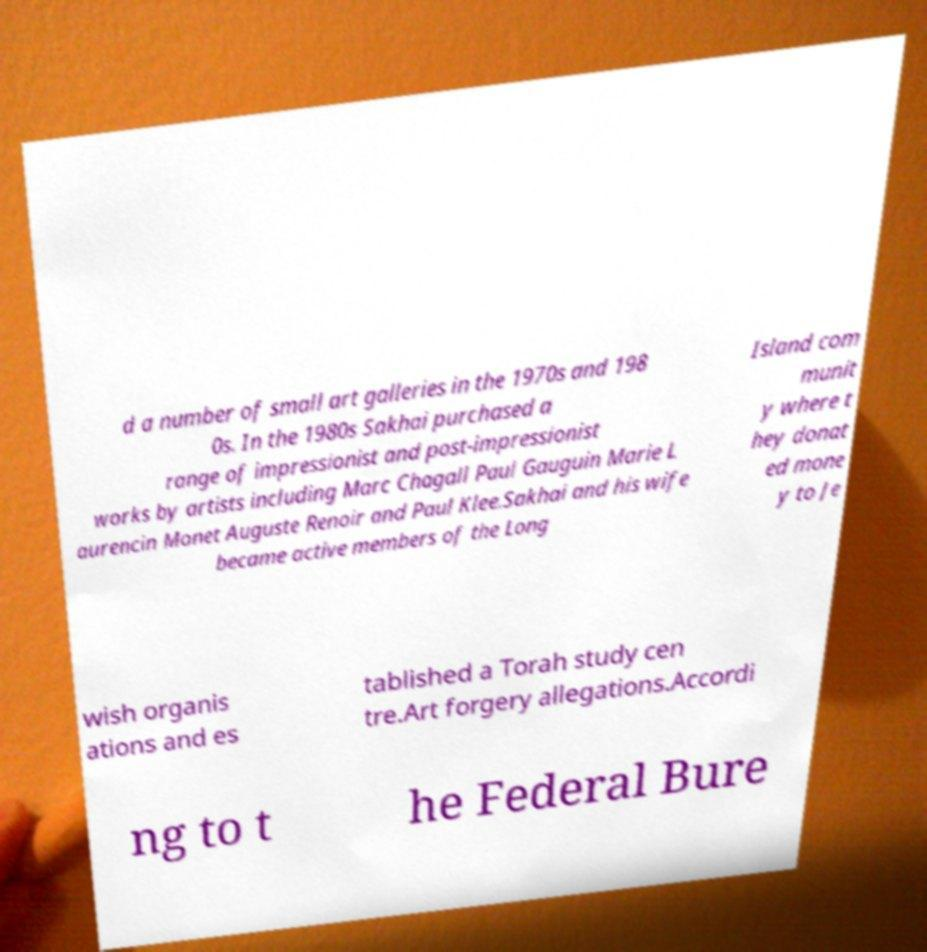Could you assist in decoding the text presented in this image and type it out clearly? d a number of small art galleries in the 1970s and 198 0s. In the 1980s Sakhai purchased a range of impressionist and post-impressionist works by artists including Marc Chagall Paul Gauguin Marie L aurencin Monet Auguste Renoir and Paul Klee.Sakhai and his wife became active members of the Long Island com munit y where t hey donat ed mone y to Je wish organis ations and es tablished a Torah study cen tre.Art forgery allegations.Accordi ng to t he Federal Bure 